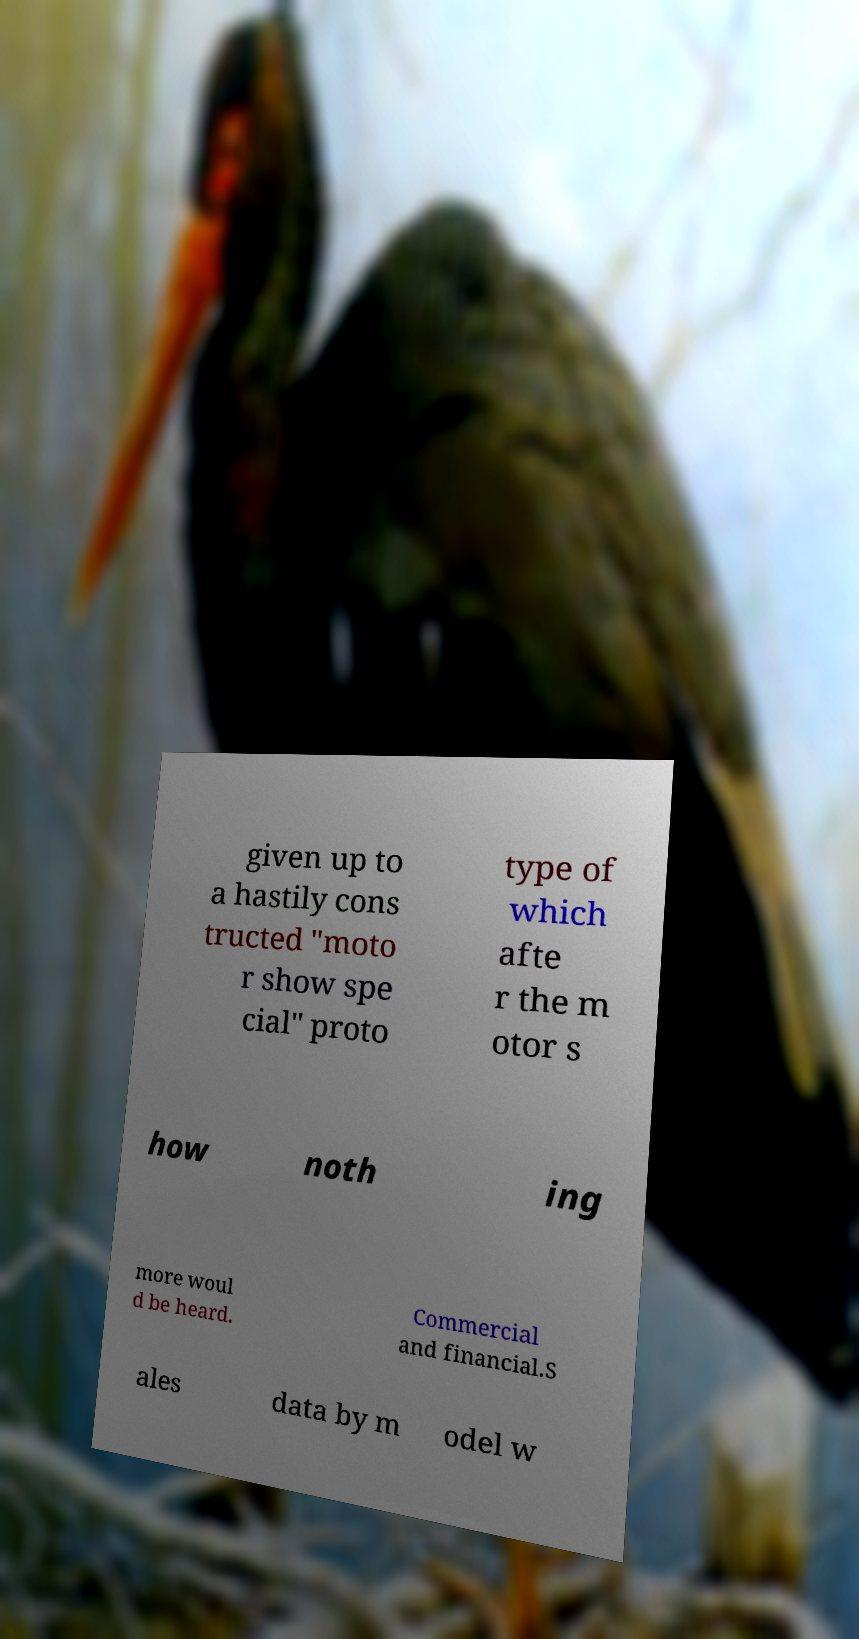Can you read and provide the text displayed in the image?This photo seems to have some interesting text. Can you extract and type it out for me? given up to a hastily cons tructed "moto r show spe cial" proto type of which afte r the m otor s how noth ing more woul d be heard. Commercial and financial.S ales data by m odel w 